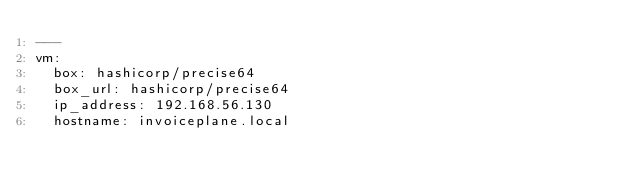Convert code to text. <code><loc_0><loc_0><loc_500><loc_500><_YAML_>---
vm:
  box: hashicorp/precise64
  box_url: hashicorp/precise64
  ip_address: 192.168.56.130
  hostname: invoiceplane.local</code> 